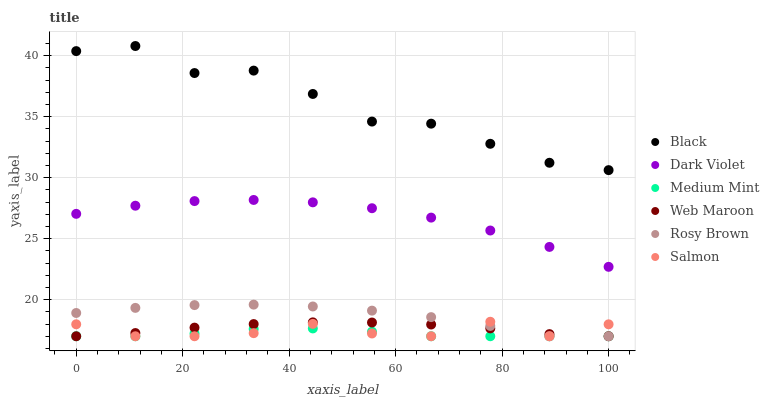Does Medium Mint have the minimum area under the curve?
Answer yes or no. Yes. Does Black have the maximum area under the curve?
Answer yes or no. Yes. Does Salmon have the minimum area under the curve?
Answer yes or no. No. Does Salmon have the maximum area under the curve?
Answer yes or no. No. Is Web Maroon the smoothest?
Answer yes or no. Yes. Is Black the roughest?
Answer yes or no. Yes. Is Salmon the smoothest?
Answer yes or no. No. Is Salmon the roughest?
Answer yes or no. No. Does Medium Mint have the lowest value?
Answer yes or no. Yes. Does Dark Violet have the lowest value?
Answer yes or no. No. Does Black have the highest value?
Answer yes or no. Yes. Does Salmon have the highest value?
Answer yes or no. No. Is Rosy Brown less than Black?
Answer yes or no. Yes. Is Dark Violet greater than Salmon?
Answer yes or no. Yes. Does Web Maroon intersect Rosy Brown?
Answer yes or no. Yes. Is Web Maroon less than Rosy Brown?
Answer yes or no. No. Is Web Maroon greater than Rosy Brown?
Answer yes or no. No. Does Rosy Brown intersect Black?
Answer yes or no. No. 